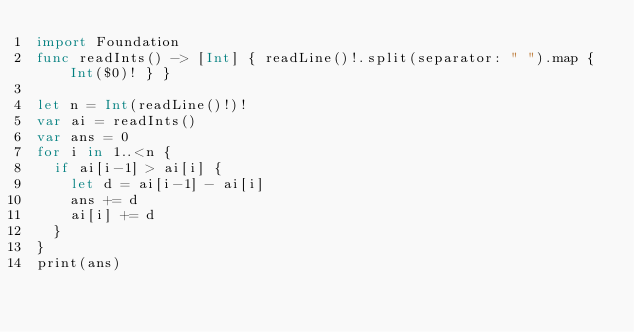Convert code to text. <code><loc_0><loc_0><loc_500><loc_500><_Swift_>import Foundation
func readInts() -> [Int] { readLine()!.split(separator: " ").map { Int($0)! } }

let n = Int(readLine()!)!
var ai = readInts()
var ans = 0
for i in 1..<n {
  if ai[i-1] > ai[i] {
    let d = ai[i-1] - ai[i]
    ans += d
    ai[i] += d
  }
}
print(ans)</code> 